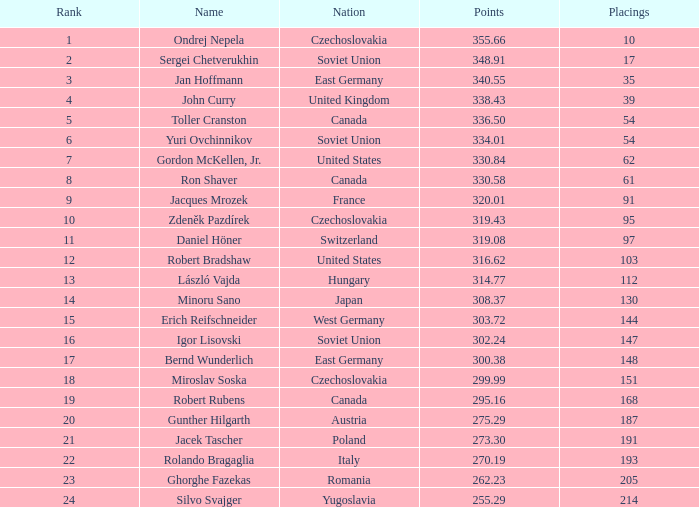Which standings belong to a country of west germany, and points surpassing 30 None. 